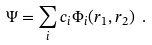Convert formula to latex. <formula><loc_0><loc_0><loc_500><loc_500>\Psi = \sum _ { i } c _ { i } \Phi _ { i } ( r _ { 1 } , r _ { 2 } ) \ .</formula> 